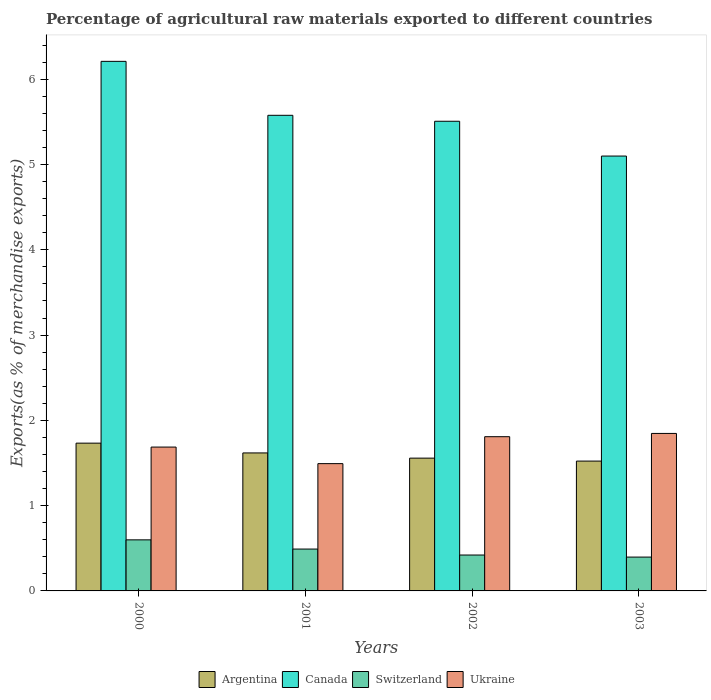How many different coloured bars are there?
Your answer should be compact. 4. Are the number of bars per tick equal to the number of legend labels?
Give a very brief answer. Yes. How many bars are there on the 4th tick from the left?
Offer a very short reply. 4. What is the label of the 3rd group of bars from the left?
Give a very brief answer. 2002. What is the percentage of exports to different countries in Switzerland in 2001?
Make the answer very short. 0.49. Across all years, what is the maximum percentage of exports to different countries in Canada?
Provide a short and direct response. 6.21. Across all years, what is the minimum percentage of exports to different countries in Canada?
Keep it short and to the point. 5.1. In which year was the percentage of exports to different countries in Ukraine maximum?
Offer a very short reply. 2003. What is the total percentage of exports to different countries in Canada in the graph?
Provide a succinct answer. 22.39. What is the difference between the percentage of exports to different countries in Switzerland in 2000 and that in 2003?
Make the answer very short. 0.2. What is the difference between the percentage of exports to different countries in Canada in 2003 and the percentage of exports to different countries in Ukraine in 2001?
Provide a short and direct response. 3.61. What is the average percentage of exports to different countries in Canada per year?
Your answer should be very brief. 5.6. In the year 2000, what is the difference between the percentage of exports to different countries in Switzerland and percentage of exports to different countries in Ukraine?
Provide a short and direct response. -1.09. What is the ratio of the percentage of exports to different countries in Switzerland in 2001 to that in 2003?
Your answer should be compact. 1.24. Is the percentage of exports to different countries in Canada in 2000 less than that in 2003?
Your answer should be very brief. No. Is the difference between the percentage of exports to different countries in Switzerland in 2000 and 2001 greater than the difference between the percentage of exports to different countries in Ukraine in 2000 and 2001?
Keep it short and to the point. No. What is the difference between the highest and the second highest percentage of exports to different countries in Switzerland?
Provide a succinct answer. 0.11. What is the difference between the highest and the lowest percentage of exports to different countries in Switzerland?
Your answer should be very brief. 0.2. In how many years, is the percentage of exports to different countries in Argentina greater than the average percentage of exports to different countries in Argentina taken over all years?
Your response must be concise. 2. Is the sum of the percentage of exports to different countries in Switzerland in 2002 and 2003 greater than the maximum percentage of exports to different countries in Argentina across all years?
Your response must be concise. No. Is it the case that in every year, the sum of the percentage of exports to different countries in Argentina and percentage of exports to different countries in Canada is greater than the sum of percentage of exports to different countries in Switzerland and percentage of exports to different countries in Ukraine?
Your response must be concise. Yes. What does the 1st bar from the left in 2001 represents?
Offer a very short reply. Argentina. How many bars are there?
Offer a terse response. 16. What is the difference between two consecutive major ticks on the Y-axis?
Your answer should be very brief. 1. Are the values on the major ticks of Y-axis written in scientific E-notation?
Your answer should be very brief. No. Does the graph contain grids?
Your answer should be compact. No. How are the legend labels stacked?
Provide a short and direct response. Horizontal. What is the title of the graph?
Ensure brevity in your answer.  Percentage of agricultural raw materials exported to different countries. Does "Mexico" appear as one of the legend labels in the graph?
Make the answer very short. No. What is the label or title of the Y-axis?
Make the answer very short. Exports(as % of merchandise exports). What is the Exports(as % of merchandise exports) in Argentina in 2000?
Give a very brief answer. 1.73. What is the Exports(as % of merchandise exports) of Canada in 2000?
Provide a succinct answer. 6.21. What is the Exports(as % of merchandise exports) in Switzerland in 2000?
Your answer should be compact. 0.6. What is the Exports(as % of merchandise exports) of Ukraine in 2000?
Keep it short and to the point. 1.69. What is the Exports(as % of merchandise exports) in Argentina in 2001?
Provide a short and direct response. 1.62. What is the Exports(as % of merchandise exports) of Canada in 2001?
Provide a short and direct response. 5.58. What is the Exports(as % of merchandise exports) in Switzerland in 2001?
Offer a very short reply. 0.49. What is the Exports(as % of merchandise exports) of Ukraine in 2001?
Offer a terse response. 1.49. What is the Exports(as % of merchandise exports) in Argentina in 2002?
Offer a very short reply. 1.56. What is the Exports(as % of merchandise exports) in Canada in 2002?
Offer a terse response. 5.51. What is the Exports(as % of merchandise exports) in Switzerland in 2002?
Offer a terse response. 0.42. What is the Exports(as % of merchandise exports) in Ukraine in 2002?
Ensure brevity in your answer.  1.81. What is the Exports(as % of merchandise exports) of Argentina in 2003?
Your answer should be compact. 1.52. What is the Exports(as % of merchandise exports) in Canada in 2003?
Provide a succinct answer. 5.1. What is the Exports(as % of merchandise exports) in Switzerland in 2003?
Keep it short and to the point. 0.4. What is the Exports(as % of merchandise exports) of Ukraine in 2003?
Make the answer very short. 1.85. Across all years, what is the maximum Exports(as % of merchandise exports) in Argentina?
Ensure brevity in your answer.  1.73. Across all years, what is the maximum Exports(as % of merchandise exports) of Canada?
Give a very brief answer. 6.21. Across all years, what is the maximum Exports(as % of merchandise exports) of Switzerland?
Offer a terse response. 0.6. Across all years, what is the maximum Exports(as % of merchandise exports) in Ukraine?
Provide a short and direct response. 1.85. Across all years, what is the minimum Exports(as % of merchandise exports) in Argentina?
Give a very brief answer. 1.52. Across all years, what is the minimum Exports(as % of merchandise exports) of Canada?
Your response must be concise. 5.1. Across all years, what is the minimum Exports(as % of merchandise exports) of Switzerland?
Give a very brief answer. 0.4. Across all years, what is the minimum Exports(as % of merchandise exports) in Ukraine?
Your answer should be very brief. 1.49. What is the total Exports(as % of merchandise exports) of Argentina in the graph?
Your answer should be very brief. 6.43. What is the total Exports(as % of merchandise exports) of Canada in the graph?
Your answer should be compact. 22.39. What is the total Exports(as % of merchandise exports) of Switzerland in the graph?
Keep it short and to the point. 1.91. What is the total Exports(as % of merchandise exports) in Ukraine in the graph?
Provide a short and direct response. 6.83. What is the difference between the Exports(as % of merchandise exports) in Argentina in 2000 and that in 2001?
Give a very brief answer. 0.11. What is the difference between the Exports(as % of merchandise exports) in Canada in 2000 and that in 2001?
Give a very brief answer. 0.63. What is the difference between the Exports(as % of merchandise exports) of Switzerland in 2000 and that in 2001?
Your answer should be compact. 0.11. What is the difference between the Exports(as % of merchandise exports) of Ukraine in 2000 and that in 2001?
Ensure brevity in your answer.  0.19. What is the difference between the Exports(as % of merchandise exports) of Argentina in 2000 and that in 2002?
Offer a very short reply. 0.18. What is the difference between the Exports(as % of merchandise exports) in Canada in 2000 and that in 2002?
Offer a terse response. 0.7. What is the difference between the Exports(as % of merchandise exports) of Switzerland in 2000 and that in 2002?
Keep it short and to the point. 0.18. What is the difference between the Exports(as % of merchandise exports) of Ukraine in 2000 and that in 2002?
Your answer should be very brief. -0.12. What is the difference between the Exports(as % of merchandise exports) in Argentina in 2000 and that in 2003?
Ensure brevity in your answer.  0.21. What is the difference between the Exports(as % of merchandise exports) of Canada in 2000 and that in 2003?
Ensure brevity in your answer.  1.11. What is the difference between the Exports(as % of merchandise exports) in Switzerland in 2000 and that in 2003?
Offer a terse response. 0.2. What is the difference between the Exports(as % of merchandise exports) of Ukraine in 2000 and that in 2003?
Give a very brief answer. -0.16. What is the difference between the Exports(as % of merchandise exports) of Argentina in 2001 and that in 2002?
Give a very brief answer. 0.06. What is the difference between the Exports(as % of merchandise exports) of Canada in 2001 and that in 2002?
Your answer should be compact. 0.07. What is the difference between the Exports(as % of merchandise exports) of Switzerland in 2001 and that in 2002?
Keep it short and to the point. 0.07. What is the difference between the Exports(as % of merchandise exports) in Ukraine in 2001 and that in 2002?
Offer a terse response. -0.32. What is the difference between the Exports(as % of merchandise exports) of Argentina in 2001 and that in 2003?
Offer a very short reply. 0.1. What is the difference between the Exports(as % of merchandise exports) in Canada in 2001 and that in 2003?
Offer a terse response. 0.48. What is the difference between the Exports(as % of merchandise exports) in Switzerland in 2001 and that in 2003?
Make the answer very short. 0.09. What is the difference between the Exports(as % of merchandise exports) of Ukraine in 2001 and that in 2003?
Your answer should be very brief. -0.35. What is the difference between the Exports(as % of merchandise exports) of Argentina in 2002 and that in 2003?
Give a very brief answer. 0.03. What is the difference between the Exports(as % of merchandise exports) in Canada in 2002 and that in 2003?
Provide a succinct answer. 0.41. What is the difference between the Exports(as % of merchandise exports) of Switzerland in 2002 and that in 2003?
Provide a succinct answer. 0.02. What is the difference between the Exports(as % of merchandise exports) in Ukraine in 2002 and that in 2003?
Make the answer very short. -0.04. What is the difference between the Exports(as % of merchandise exports) in Argentina in 2000 and the Exports(as % of merchandise exports) in Canada in 2001?
Your answer should be very brief. -3.84. What is the difference between the Exports(as % of merchandise exports) in Argentina in 2000 and the Exports(as % of merchandise exports) in Switzerland in 2001?
Offer a very short reply. 1.24. What is the difference between the Exports(as % of merchandise exports) in Argentina in 2000 and the Exports(as % of merchandise exports) in Ukraine in 2001?
Ensure brevity in your answer.  0.24. What is the difference between the Exports(as % of merchandise exports) of Canada in 2000 and the Exports(as % of merchandise exports) of Switzerland in 2001?
Keep it short and to the point. 5.72. What is the difference between the Exports(as % of merchandise exports) in Canada in 2000 and the Exports(as % of merchandise exports) in Ukraine in 2001?
Provide a short and direct response. 4.72. What is the difference between the Exports(as % of merchandise exports) of Switzerland in 2000 and the Exports(as % of merchandise exports) of Ukraine in 2001?
Provide a succinct answer. -0.89. What is the difference between the Exports(as % of merchandise exports) of Argentina in 2000 and the Exports(as % of merchandise exports) of Canada in 2002?
Provide a succinct answer. -3.77. What is the difference between the Exports(as % of merchandise exports) in Argentina in 2000 and the Exports(as % of merchandise exports) in Switzerland in 2002?
Ensure brevity in your answer.  1.31. What is the difference between the Exports(as % of merchandise exports) of Argentina in 2000 and the Exports(as % of merchandise exports) of Ukraine in 2002?
Offer a terse response. -0.08. What is the difference between the Exports(as % of merchandise exports) in Canada in 2000 and the Exports(as % of merchandise exports) in Switzerland in 2002?
Keep it short and to the point. 5.79. What is the difference between the Exports(as % of merchandise exports) of Canada in 2000 and the Exports(as % of merchandise exports) of Ukraine in 2002?
Offer a terse response. 4.4. What is the difference between the Exports(as % of merchandise exports) in Switzerland in 2000 and the Exports(as % of merchandise exports) in Ukraine in 2002?
Your response must be concise. -1.21. What is the difference between the Exports(as % of merchandise exports) of Argentina in 2000 and the Exports(as % of merchandise exports) of Canada in 2003?
Your response must be concise. -3.37. What is the difference between the Exports(as % of merchandise exports) in Argentina in 2000 and the Exports(as % of merchandise exports) in Switzerland in 2003?
Ensure brevity in your answer.  1.34. What is the difference between the Exports(as % of merchandise exports) of Argentina in 2000 and the Exports(as % of merchandise exports) of Ukraine in 2003?
Offer a terse response. -0.11. What is the difference between the Exports(as % of merchandise exports) in Canada in 2000 and the Exports(as % of merchandise exports) in Switzerland in 2003?
Give a very brief answer. 5.81. What is the difference between the Exports(as % of merchandise exports) of Canada in 2000 and the Exports(as % of merchandise exports) of Ukraine in 2003?
Your response must be concise. 4.36. What is the difference between the Exports(as % of merchandise exports) of Switzerland in 2000 and the Exports(as % of merchandise exports) of Ukraine in 2003?
Your response must be concise. -1.25. What is the difference between the Exports(as % of merchandise exports) in Argentina in 2001 and the Exports(as % of merchandise exports) in Canada in 2002?
Keep it short and to the point. -3.89. What is the difference between the Exports(as % of merchandise exports) in Argentina in 2001 and the Exports(as % of merchandise exports) in Switzerland in 2002?
Offer a terse response. 1.2. What is the difference between the Exports(as % of merchandise exports) in Argentina in 2001 and the Exports(as % of merchandise exports) in Ukraine in 2002?
Offer a very short reply. -0.19. What is the difference between the Exports(as % of merchandise exports) in Canada in 2001 and the Exports(as % of merchandise exports) in Switzerland in 2002?
Offer a terse response. 5.16. What is the difference between the Exports(as % of merchandise exports) in Canada in 2001 and the Exports(as % of merchandise exports) in Ukraine in 2002?
Provide a succinct answer. 3.77. What is the difference between the Exports(as % of merchandise exports) of Switzerland in 2001 and the Exports(as % of merchandise exports) of Ukraine in 2002?
Make the answer very short. -1.32. What is the difference between the Exports(as % of merchandise exports) in Argentina in 2001 and the Exports(as % of merchandise exports) in Canada in 2003?
Keep it short and to the point. -3.48. What is the difference between the Exports(as % of merchandise exports) in Argentina in 2001 and the Exports(as % of merchandise exports) in Switzerland in 2003?
Your answer should be very brief. 1.22. What is the difference between the Exports(as % of merchandise exports) in Argentina in 2001 and the Exports(as % of merchandise exports) in Ukraine in 2003?
Keep it short and to the point. -0.23. What is the difference between the Exports(as % of merchandise exports) of Canada in 2001 and the Exports(as % of merchandise exports) of Switzerland in 2003?
Make the answer very short. 5.18. What is the difference between the Exports(as % of merchandise exports) of Canada in 2001 and the Exports(as % of merchandise exports) of Ukraine in 2003?
Offer a terse response. 3.73. What is the difference between the Exports(as % of merchandise exports) of Switzerland in 2001 and the Exports(as % of merchandise exports) of Ukraine in 2003?
Your answer should be very brief. -1.36. What is the difference between the Exports(as % of merchandise exports) of Argentina in 2002 and the Exports(as % of merchandise exports) of Canada in 2003?
Your answer should be compact. -3.54. What is the difference between the Exports(as % of merchandise exports) in Argentina in 2002 and the Exports(as % of merchandise exports) in Switzerland in 2003?
Ensure brevity in your answer.  1.16. What is the difference between the Exports(as % of merchandise exports) in Argentina in 2002 and the Exports(as % of merchandise exports) in Ukraine in 2003?
Your answer should be compact. -0.29. What is the difference between the Exports(as % of merchandise exports) in Canada in 2002 and the Exports(as % of merchandise exports) in Switzerland in 2003?
Make the answer very short. 5.11. What is the difference between the Exports(as % of merchandise exports) in Canada in 2002 and the Exports(as % of merchandise exports) in Ukraine in 2003?
Your answer should be compact. 3.66. What is the difference between the Exports(as % of merchandise exports) in Switzerland in 2002 and the Exports(as % of merchandise exports) in Ukraine in 2003?
Provide a succinct answer. -1.43. What is the average Exports(as % of merchandise exports) of Argentina per year?
Ensure brevity in your answer.  1.61. What is the average Exports(as % of merchandise exports) in Canada per year?
Ensure brevity in your answer.  5.6. What is the average Exports(as % of merchandise exports) of Switzerland per year?
Make the answer very short. 0.48. What is the average Exports(as % of merchandise exports) in Ukraine per year?
Provide a succinct answer. 1.71. In the year 2000, what is the difference between the Exports(as % of merchandise exports) of Argentina and Exports(as % of merchandise exports) of Canada?
Your answer should be very brief. -4.48. In the year 2000, what is the difference between the Exports(as % of merchandise exports) in Argentina and Exports(as % of merchandise exports) in Switzerland?
Offer a very short reply. 1.13. In the year 2000, what is the difference between the Exports(as % of merchandise exports) in Argentina and Exports(as % of merchandise exports) in Ukraine?
Make the answer very short. 0.05. In the year 2000, what is the difference between the Exports(as % of merchandise exports) in Canada and Exports(as % of merchandise exports) in Switzerland?
Your response must be concise. 5.61. In the year 2000, what is the difference between the Exports(as % of merchandise exports) in Canada and Exports(as % of merchandise exports) in Ukraine?
Make the answer very short. 4.52. In the year 2000, what is the difference between the Exports(as % of merchandise exports) of Switzerland and Exports(as % of merchandise exports) of Ukraine?
Give a very brief answer. -1.09. In the year 2001, what is the difference between the Exports(as % of merchandise exports) in Argentina and Exports(as % of merchandise exports) in Canada?
Your answer should be very brief. -3.96. In the year 2001, what is the difference between the Exports(as % of merchandise exports) of Argentina and Exports(as % of merchandise exports) of Switzerland?
Offer a terse response. 1.13. In the year 2001, what is the difference between the Exports(as % of merchandise exports) of Argentina and Exports(as % of merchandise exports) of Ukraine?
Ensure brevity in your answer.  0.13. In the year 2001, what is the difference between the Exports(as % of merchandise exports) of Canada and Exports(as % of merchandise exports) of Switzerland?
Give a very brief answer. 5.09. In the year 2001, what is the difference between the Exports(as % of merchandise exports) in Canada and Exports(as % of merchandise exports) in Ukraine?
Your response must be concise. 4.08. In the year 2001, what is the difference between the Exports(as % of merchandise exports) in Switzerland and Exports(as % of merchandise exports) in Ukraine?
Provide a succinct answer. -1. In the year 2002, what is the difference between the Exports(as % of merchandise exports) in Argentina and Exports(as % of merchandise exports) in Canada?
Give a very brief answer. -3.95. In the year 2002, what is the difference between the Exports(as % of merchandise exports) in Argentina and Exports(as % of merchandise exports) in Switzerland?
Your response must be concise. 1.14. In the year 2002, what is the difference between the Exports(as % of merchandise exports) in Argentina and Exports(as % of merchandise exports) in Ukraine?
Keep it short and to the point. -0.25. In the year 2002, what is the difference between the Exports(as % of merchandise exports) in Canada and Exports(as % of merchandise exports) in Switzerland?
Offer a very short reply. 5.09. In the year 2002, what is the difference between the Exports(as % of merchandise exports) of Canada and Exports(as % of merchandise exports) of Ukraine?
Your answer should be very brief. 3.7. In the year 2002, what is the difference between the Exports(as % of merchandise exports) in Switzerland and Exports(as % of merchandise exports) in Ukraine?
Keep it short and to the point. -1.39. In the year 2003, what is the difference between the Exports(as % of merchandise exports) of Argentina and Exports(as % of merchandise exports) of Canada?
Provide a short and direct response. -3.58. In the year 2003, what is the difference between the Exports(as % of merchandise exports) of Argentina and Exports(as % of merchandise exports) of Switzerland?
Your answer should be compact. 1.13. In the year 2003, what is the difference between the Exports(as % of merchandise exports) of Argentina and Exports(as % of merchandise exports) of Ukraine?
Keep it short and to the point. -0.32. In the year 2003, what is the difference between the Exports(as % of merchandise exports) of Canada and Exports(as % of merchandise exports) of Switzerland?
Your answer should be very brief. 4.7. In the year 2003, what is the difference between the Exports(as % of merchandise exports) of Canada and Exports(as % of merchandise exports) of Ukraine?
Your answer should be compact. 3.25. In the year 2003, what is the difference between the Exports(as % of merchandise exports) in Switzerland and Exports(as % of merchandise exports) in Ukraine?
Provide a short and direct response. -1.45. What is the ratio of the Exports(as % of merchandise exports) in Argentina in 2000 to that in 2001?
Your answer should be very brief. 1.07. What is the ratio of the Exports(as % of merchandise exports) of Canada in 2000 to that in 2001?
Keep it short and to the point. 1.11. What is the ratio of the Exports(as % of merchandise exports) in Switzerland in 2000 to that in 2001?
Give a very brief answer. 1.22. What is the ratio of the Exports(as % of merchandise exports) of Ukraine in 2000 to that in 2001?
Your answer should be very brief. 1.13. What is the ratio of the Exports(as % of merchandise exports) in Argentina in 2000 to that in 2002?
Provide a short and direct response. 1.11. What is the ratio of the Exports(as % of merchandise exports) of Canada in 2000 to that in 2002?
Ensure brevity in your answer.  1.13. What is the ratio of the Exports(as % of merchandise exports) of Switzerland in 2000 to that in 2002?
Make the answer very short. 1.42. What is the ratio of the Exports(as % of merchandise exports) in Ukraine in 2000 to that in 2002?
Offer a terse response. 0.93. What is the ratio of the Exports(as % of merchandise exports) in Argentina in 2000 to that in 2003?
Make the answer very short. 1.14. What is the ratio of the Exports(as % of merchandise exports) in Canada in 2000 to that in 2003?
Give a very brief answer. 1.22. What is the ratio of the Exports(as % of merchandise exports) in Switzerland in 2000 to that in 2003?
Keep it short and to the point. 1.51. What is the ratio of the Exports(as % of merchandise exports) of Ukraine in 2000 to that in 2003?
Keep it short and to the point. 0.91. What is the ratio of the Exports(as % of merchandise exports) in Argentina in 2001 to that in 2002?
Keep it short and to the point. 1.04. What is the ratio of the Exports(as % of merchandise exports) of Canada in 2001 to that in 2002?
Provide a succinct answer. 1.01. What is the ratio of the Exports(as % of merchandise exports) of Switzerland in 2001 to that in 2002?
Provide a short and direct response. 1.17. What is the ratio of the Exports(as % of merchandise exports) of Ukraine in 2001 to that in 2002?
Provide a succinct answer. 0.83. What is the ratio of the Exports(as % of merchandise exports) in Argentina in 2001 to that in 2003?
Ensure brevity in your answer.  1.06. What is the ratio of the Exports(as % of merchandise exports) of Canada in 2001 to that in 2003?
Provide a succinct answer. 1.09. What is the ratio of the Exports(as % of merchandise exports) in Switzerland in 2001 to that in 2003?
Your answer should be very brief. 1.24. What is the ratio of the Exports(as % of merchandise exports) in Ukraine in 2001 to that in 2003?
Offer a very short reply. 0.81. What is the ratio of the Exports(as % of merchandise exports) of Argentina in 2002 to that in 2003?
Your answer should be compact. 1.02. What is the ratio of the Exports(as % of merchandise exports) of Canada in 2002 to that in 2003?
Offer a very short reply. 1.08. What is the ratio of the Exports(as % of merchandise exports) of Switzerland in 2002 to that in 2003?
Your answer should be compact. 1.06. What is the ratio of the Exports(as % of merchandise exports) in Ukraine in 2002 to that in 2003?
Keep it short and to the point. 0.98. What is the difference between the highest and the second highest Exports(as % of merchandise exports) of Argentina?
Make the answer very short. 0.11. What is the difference between the highest and the second highest Exports(as % of merchandise exports) of Canada?
Provide a succinct answer. 0.63. What is the difference between the highest and the second highest Exports(as % of merchandise exports) in Switzerland?
Offer a very short reply. 0.11. What is the difference between the highest and the second highest Exports(as % of merchandise exports) in Ukraine?
Your answer should be compact. 0.04. What is the difference between the highest and the lowest Exports(as % of merchandise exports) of Argentina?
Offer a terse response. 0.21. What is the difference between the highest and the lowest Exports(as % of merchandise exports) of Canada?
Ensure brevity in your answer.  1.11. What is the difference between the highest and the lowest Exports(as % of merchandise exports) in Switzerland?
Provide a succinct answer. 0.2. What is the difference between the highest and the lowest Exports(as % of merchandise exports) of Ukraine?
Give a very brief answer. 0.35. 